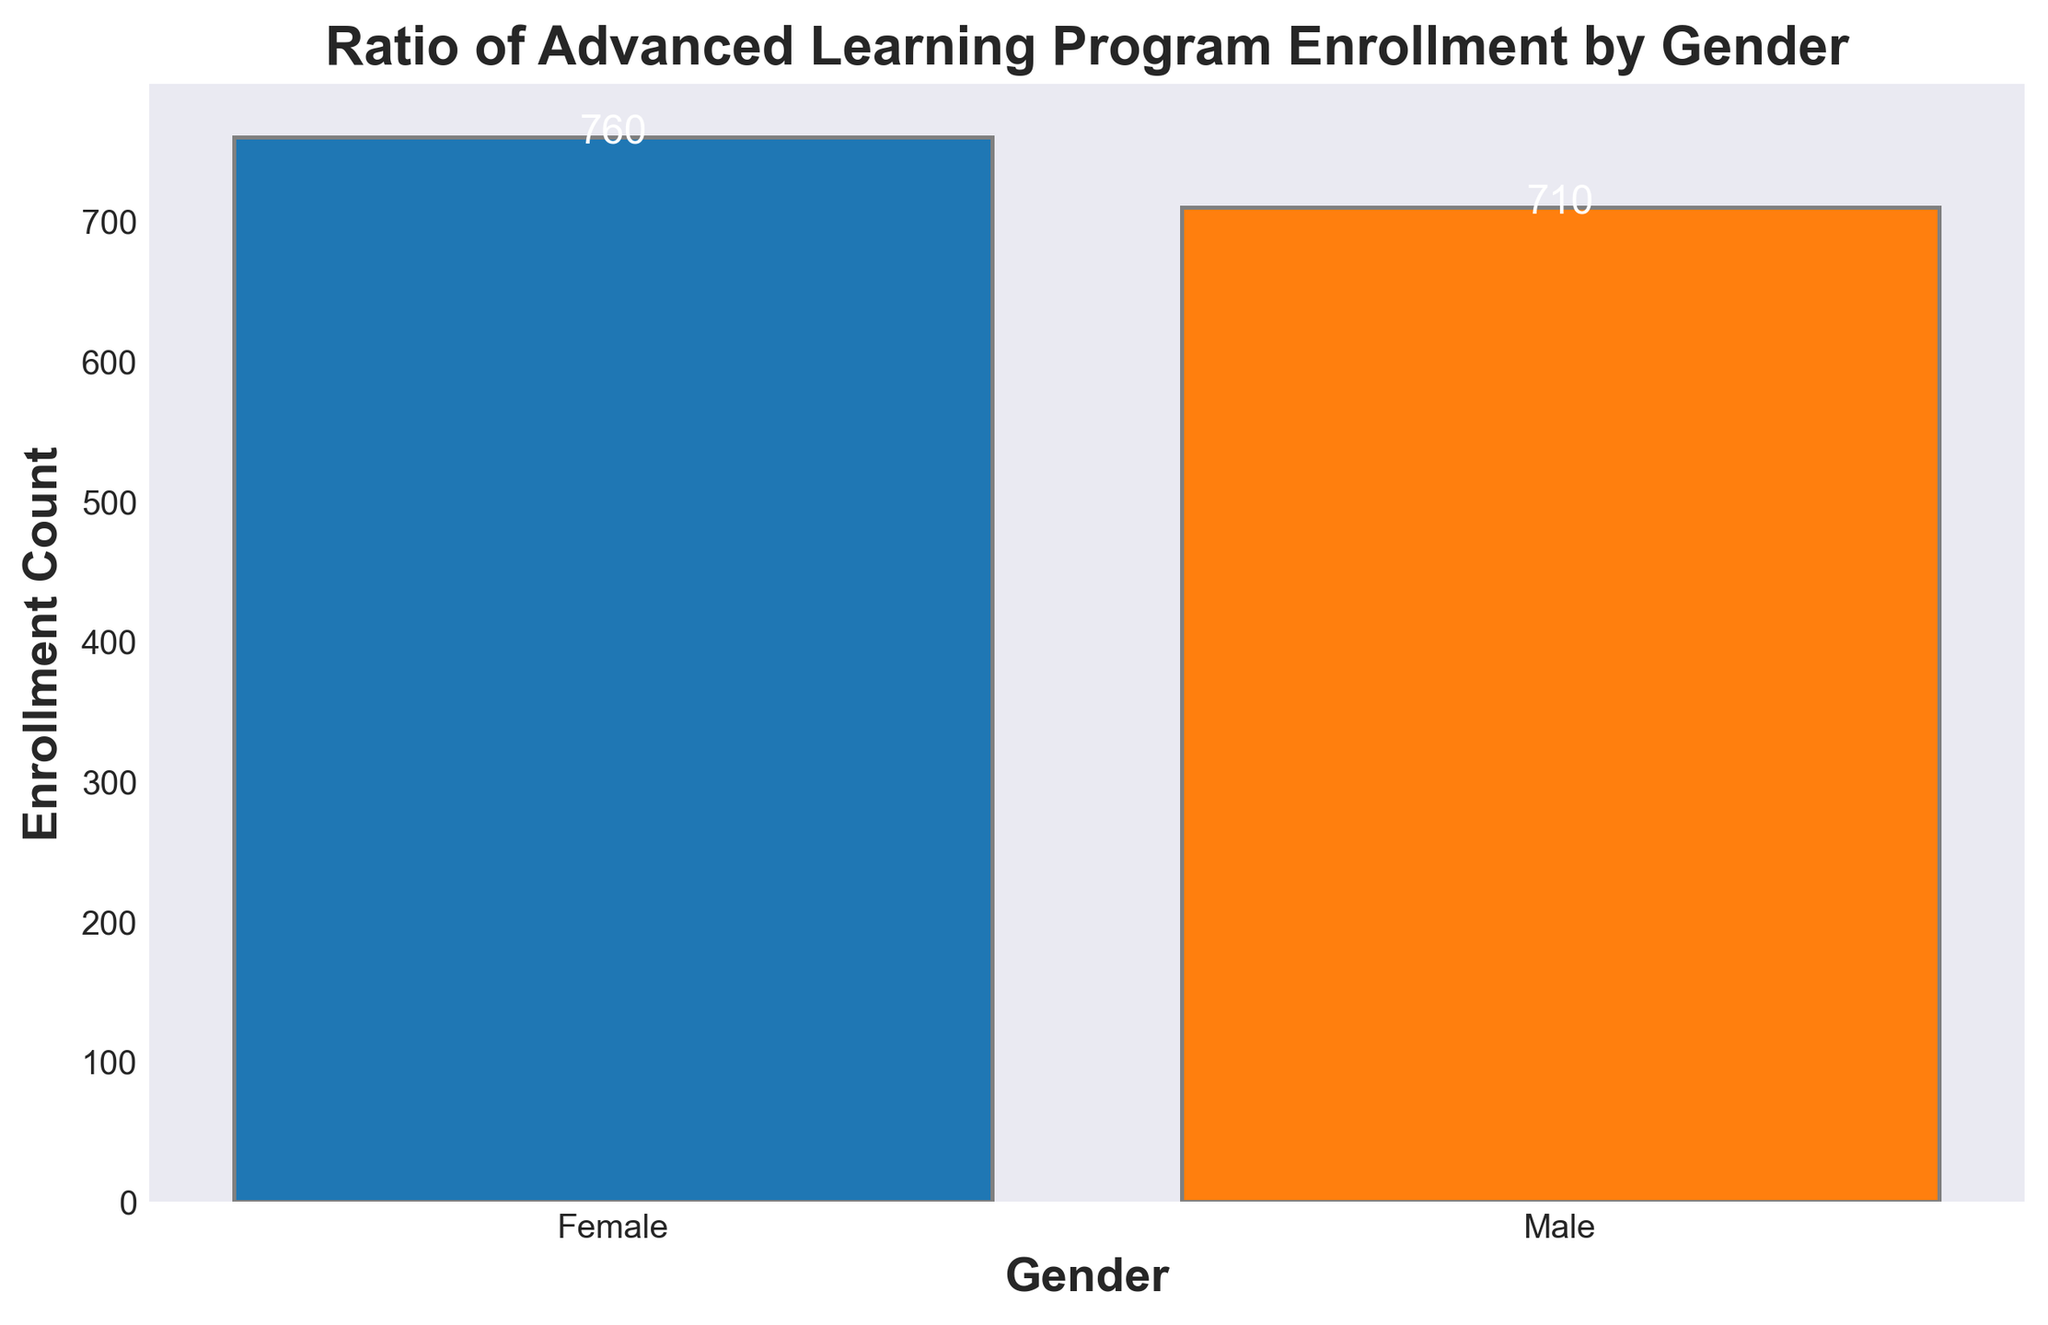What's the total enrollment count for both genders combined? To find the total enrollment count, we sum the enrollment counts for both genders: 710 (Male) + 760 (Female) = 1470
Answer: 1470 Which gender has a higher enrollment count? The bar representing females is taller than the bar representing males, indicating the enrollment count for females (760) is higher than for males (710)
Answer: Female By how much do females exceed males in the enrollment count? First, find the difference between the enrollment counts of females and males: 760 (Female) - 710 (Male) = 50
Answer: 50 What's the ratio of male to female enrollment count? To determine the ratio, divide the enrollment count of males by the count of females: 710 / 760 ≈ 0.9342
Answer: 0.9342 If the total enrollment for Advanced Learning Programs doubled, what would be the enrollment count for each gender? Doubling the total enrollment (1470) gives 2940. The proportion remains the same, so we calculate it as follows:
  - Males: 710 * 2 = 1420 
  - Females: 760 * 2 = 1520
Answer: 1420 (Male), 1520 (Female) What is the percentage increase in the enrollment count from males to females? Calculate the percentage increase using the formula [(new value - old value) / old value] * 100:
  - Difference = 760 - 710 = 50
  - Percentage increase = (50 / 710) * 100 ≈ 7.04%
Answer: 7.04% What is the combined average enrollment count per gender? To find the average, sum the enrollment counts and then divide by 2:
  - Total enrollment count = 710 (Male) + 760 (Female) = 1470
  - Average = 1470 / 2 = 735
Answer: 735 How many more females are there compared to males if we consider the next year's projected increase of 10% for both genders? Calculate new counts with a 10% increase:
  - Male: 710 + (710 * 0.1) = 781
  - Female: 760 + (760 * 0.1) = 836
  - Difference: 836 - 781 = 55
Answer: 55 